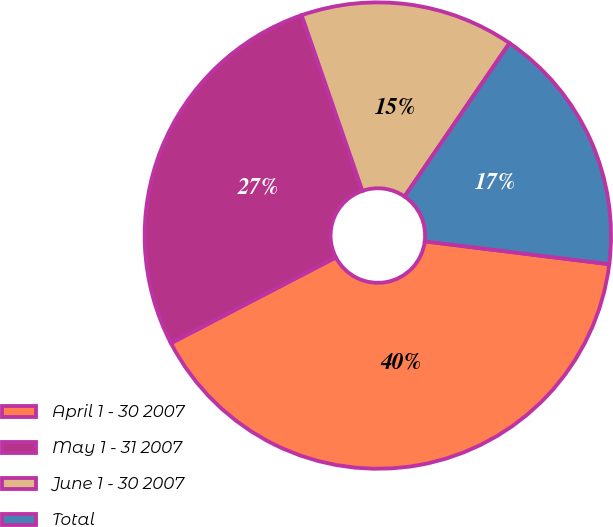Convert chart. <chart><loc_0><loc_0><loc_500><loc_500><pie_chart><fcel>April 1 - 30 2007<fcel>May 1 - 31 2007<fcel>June 1 - 30 2007<fcel>Total<nl><fcel>40.41%<fcel>27.33%<fcel>14.85%<fcel>17.41%<nl></chart> 